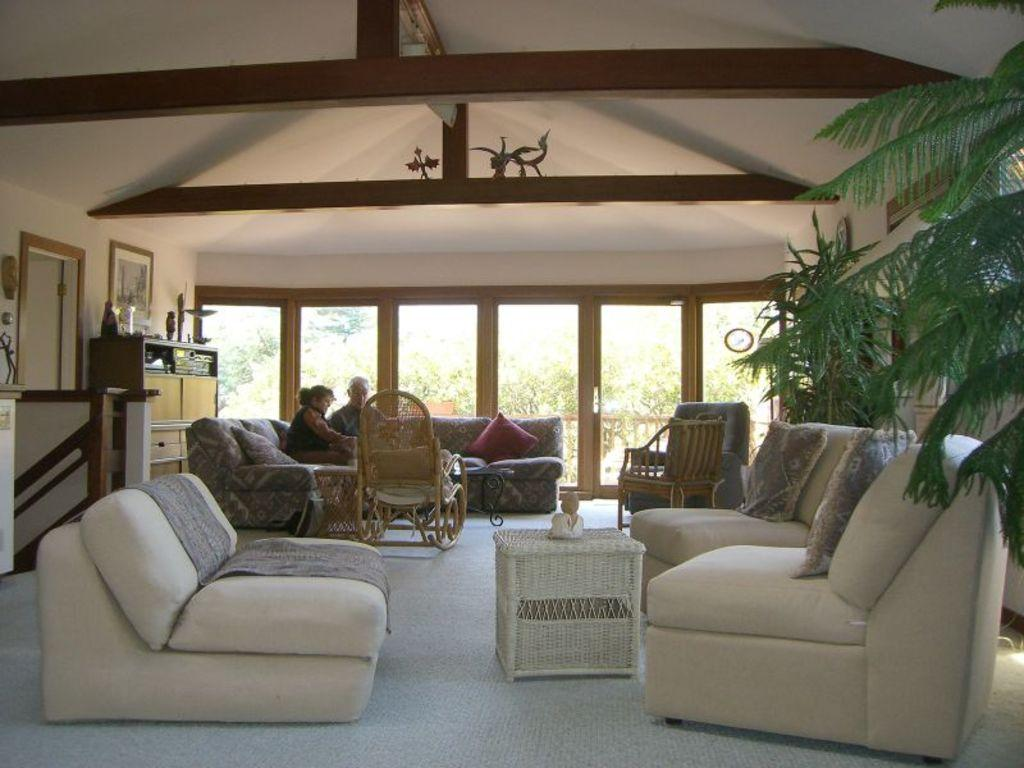What type of furniture is in front of the table in the image? There are sofas in front of the table in the image. What can be seen in the right corner of the image? There is a tree in the right corner of the image. Are there any people visible in the image? Yes, there are two people sitting in a sofa in the background. What type of toothpaste is on the table? There is no toothpaste mentioned in the facts, and it is not visible in the image. 